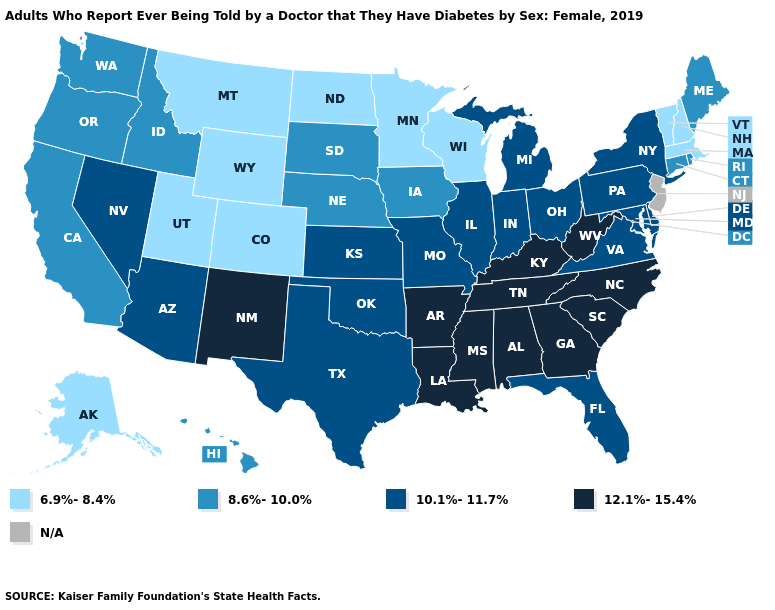What is the value of Wisconsin?
Keep it brief. 6.9%-8.4%. What is the highest value in states that border Montana?
Be succinct. 8.6%-10.0%. Does the first symbol in the legend represent the smallest category?
Short answer required. Yes. Does Louisiana have the lowest value in the USA?
Short answer required. No. Does Indiana have the lowest value in the USA?
Write a very short answer. No. What is the lowest value in the USA?
Quick response, please. 6.9%-8.4%. Which states have the lowest value in the Northeast?
Answer briefly. Massachusetts, New Hampshire, Vermont. Does Colorado have the highest value in the West?
Be succinct. No. Which states hav the highest value in the West?
Be succinct. New Mexico. What is the lowest value in the USA?
Quick response, please. 6.9%-8.4%. Name the states that have a value in the range 6.9%-8.4%?
Give a very brief answer. Alaska, Colorado, Massachusetts, Minnesota, Montana, New Hampshire, North Dakota, Utah, Vermont, Wisconsin, Wyoming. What is the value of North Dakota?
Keep it brief. 6.9%-8.4%. What is the lowest value in the USA?
Short answer required. 6.9%-8.4%. 